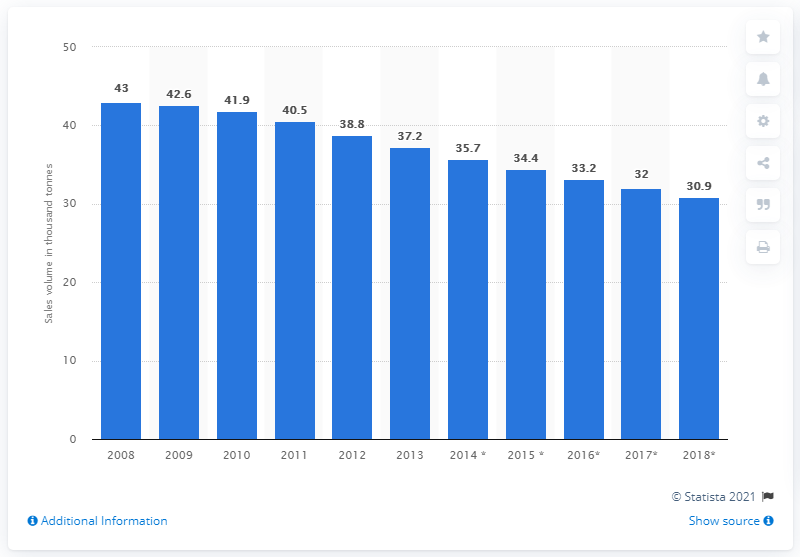Give some essential details in this illustration. The sales volume of pineapple began to decline in 2009. 